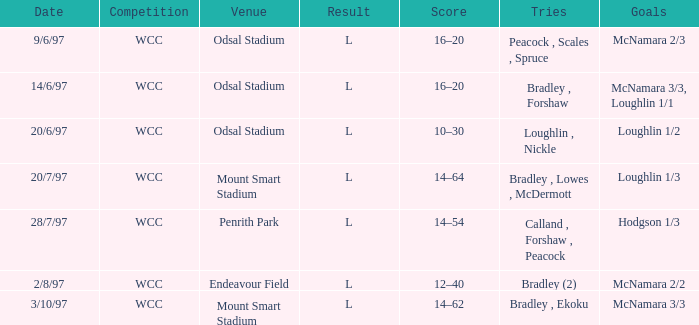What were the endeavors on 14/6/97? Bradley , Forshaw. 